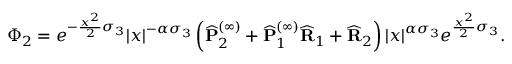Convert formula to latex. <formula><loc_0><loc_0><loc_500><loc_500>\Phi _ { 2 } = e ^ { - \frac { x ^ { 2 } } { 2 } \sigma _ { 3 } } | x | ^ { - \alpha \sigma _ { 3 } } \left ( \widehat { P } _ { 2 } ^ { ( \infty ) } + \widehat { P } _ { 1 } ^ { ( \infty ) } \widehat { R } _ { 1 } + \widehat { R } _ { 2 } \right ) | x | ^ { \alpha \sigma _ { 3 } } e ^ { \frac { x ^ { 2 } } { 2 } \sigma _ { 3 } } .</formula> 